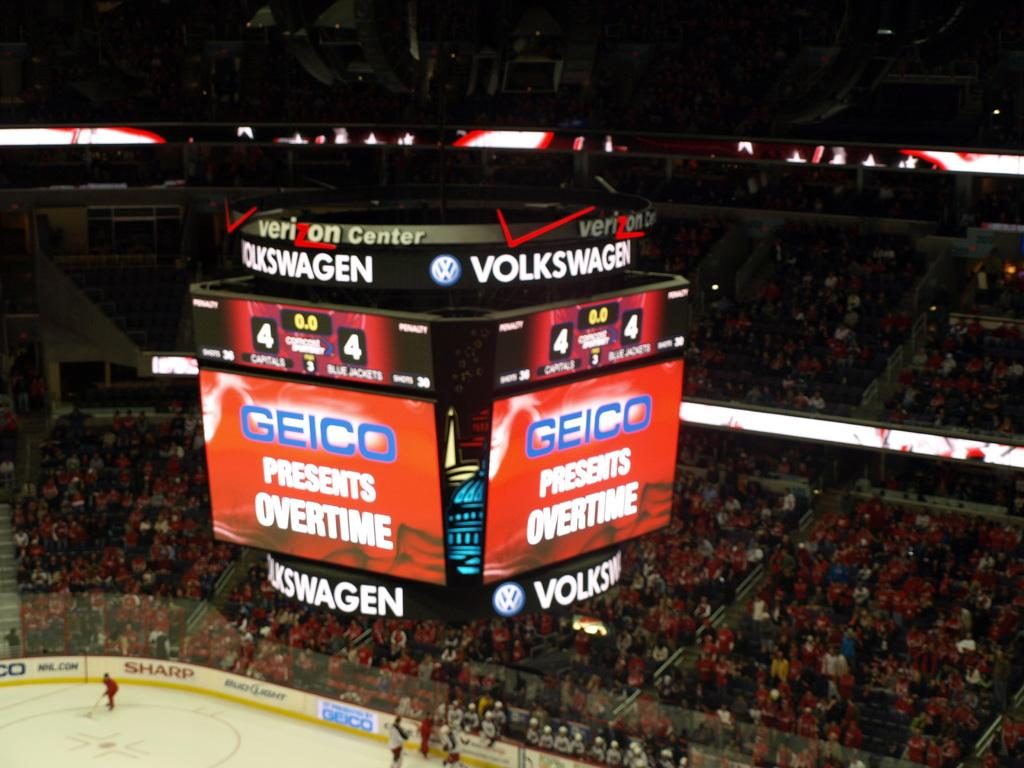Provide a one-sentence caption for the provided image. The hockey game is about to go into overtime. 